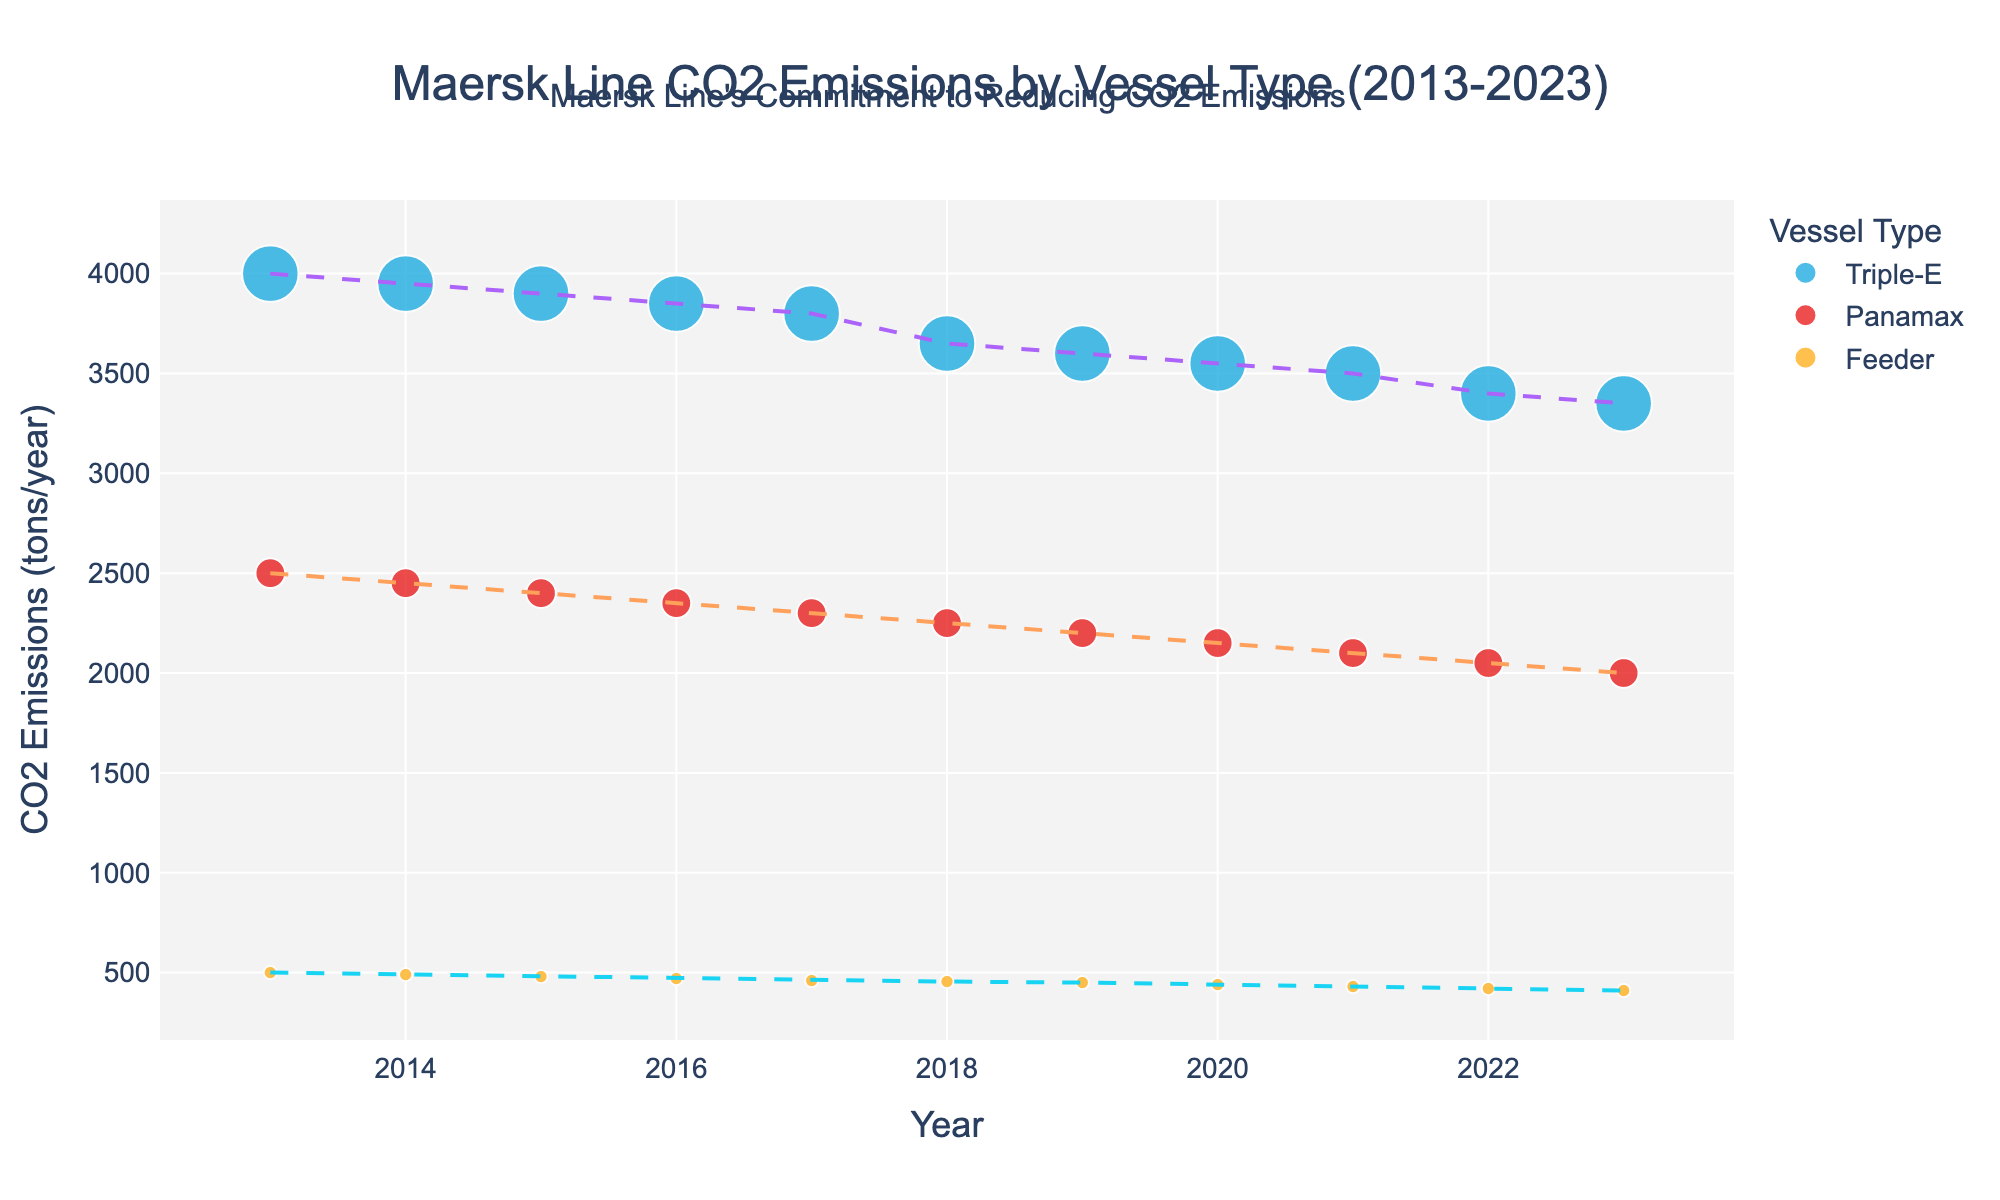How many vessel types are displayed in the plot? The plot categorizes CO2 emissions by vessel type, and we can see the distinct vessel types listed in the legend. We identify three different vessel types shown in the plot: Triple-E, Panamax, and Feeder.
Answer: 3 What is the overall trend in CO2 emissions for Triple-E vessels over the past decade? The trend line for the Triple-E vessels shows a declining pattern. Starting from 4000 tons/year in 2013, the emissions consistently decrease each year, reaching 3350 tons/year in 2023.
Answer: Decreasing Which vessel type has the highest CO2 emissions in 2015? By comparing the data points for 2015, we see that the Triple-E vessels have the highest emissions compared to Panamax and Feeder vessels, with 3900 tons/year.
Answer: Triple-E What is the difference in CO2 emissions between the Triple-E and Panamax vessels in 2020? From the plot, we identify the CO2 emissions for Triple-E vessels in 2020 is 3550 tons/year, and for Panamax vessels, it is 2150 tons/year. The difference is 3550 - 2150 = 1400 tons/year.
Answer: 1400 tons/year How did the CO2 emissions of Feeder vessels change from 2013 to 2023? The plot shows that Feeder vessels' CO2 emissions in 2013 were 500 tons/year, and in 2023, they were 410 tons/year. This indicates a decrease of 500 - 410 = 90 tons/year over the period.
Answer: Decreased by 90 tons/year Which year saw the most significant reduction in CO2 emissions for Triple-E vessels? Observing the plot's data points for Triple-E vessels, the most significant year-on-year reduction occurs between 2017 and 2018, where emissions drop from around 3800 tons/year to 3650 tons/year, a reduction of 150 tons/year.
Answer: 2017 to 2018 Which vessel type shows the least decline in CO2 emissions from 2013 to 2023? By comparing the start and end points for each vessel type, the Feeder vessels start at 500 tons/year in 2013 and end at 410 tons/year in 2023, a decline of 90 tons/year, which is less than that of the other vessel types.
Answer: Feeder What is the average CO2 emissions for Panamax vessels across the decade? The CO2 emissions for Panamax vessels over the years are: 2500, 2450, 2400, 2350, 2300, 2250, 2200, 2150, 2100, 2050, 2000. Summing these up: 2500 + 2450 + 2400 + 2350 + 2300 + 2250 + 2200 + 2150 + 2100 + 2050 + 2000 = 24650. The number of years is 11. Therefore, the average is 24650 / 11 ≈ 2240.91 tons/year.
Answer: 2240.91 tons/year Which vessel type has the largest bubble size on the scatter plot? Bubble size on the scatter plot corresponds to the vessel size (TEU). The Triple-E vessels have the largest reported size at 18000 TEU, which makes their bubbles the largest.
Answer: Triple-E 